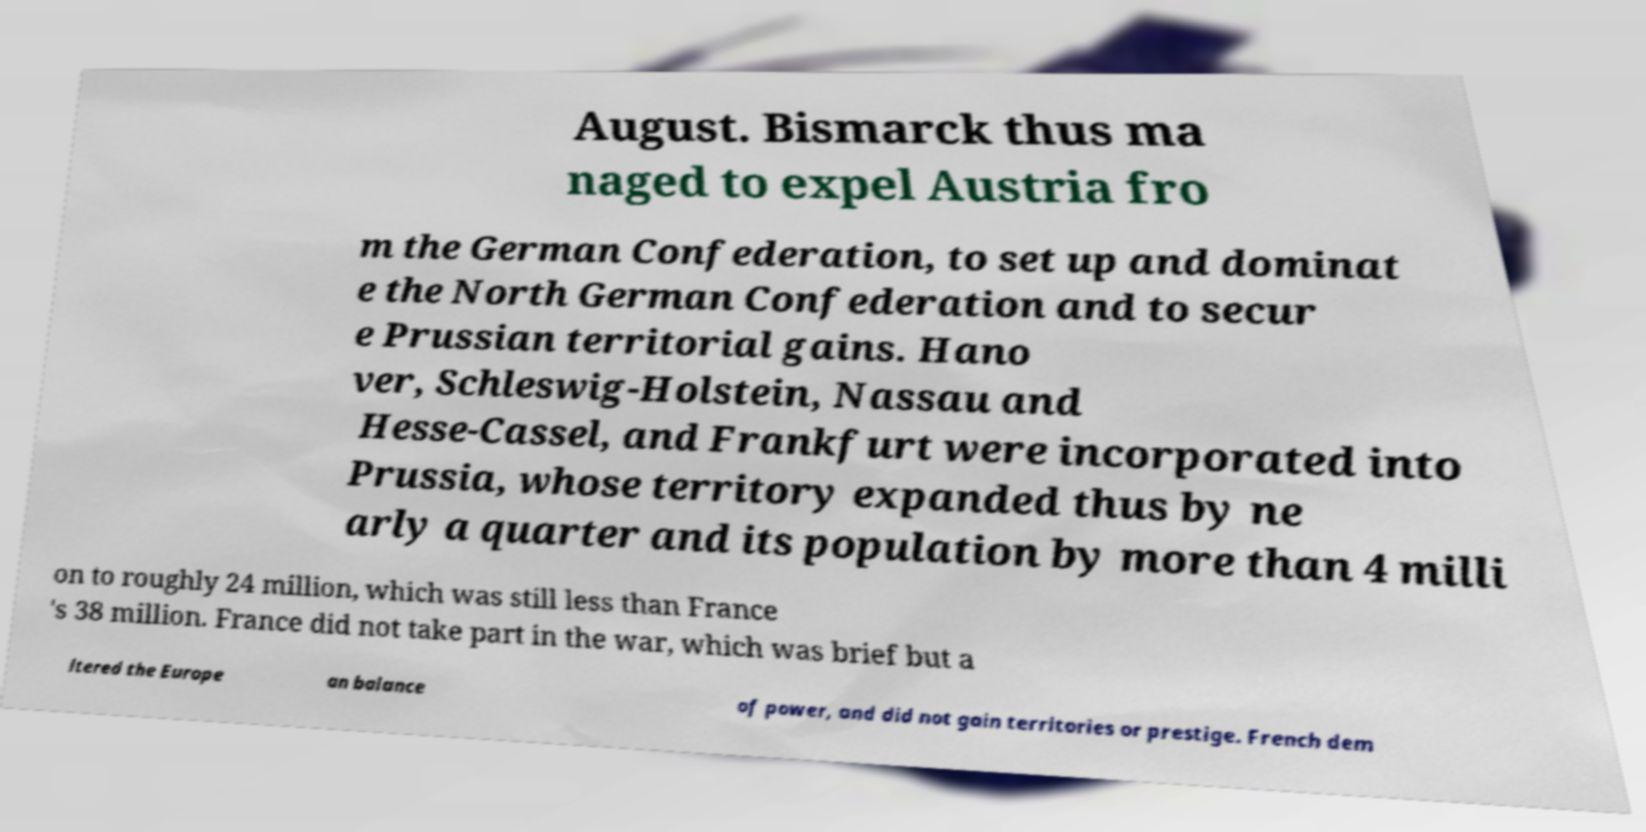Could you assist in decoding the text presented in this image and type it out clearly? August. Bismarck thus ma naged to expel Austria fro m the German Confederation, to set up and dominat e the North German Confederation and to secur e Prussian territorial gains. Hano ver, Schleswig-Holstein, Nassau and Hesse-Cassel, and Frankfurt were incorporated into Prussia, whose territory expanded thus by ne arly a quarter and its population by more than 4 milli on to roughly 24 million, which was still less than France 's 38 million. France did not take part in the war, which was brief but a ltered the Europe an balance of power, and did not gain territories or prestige. French dem 